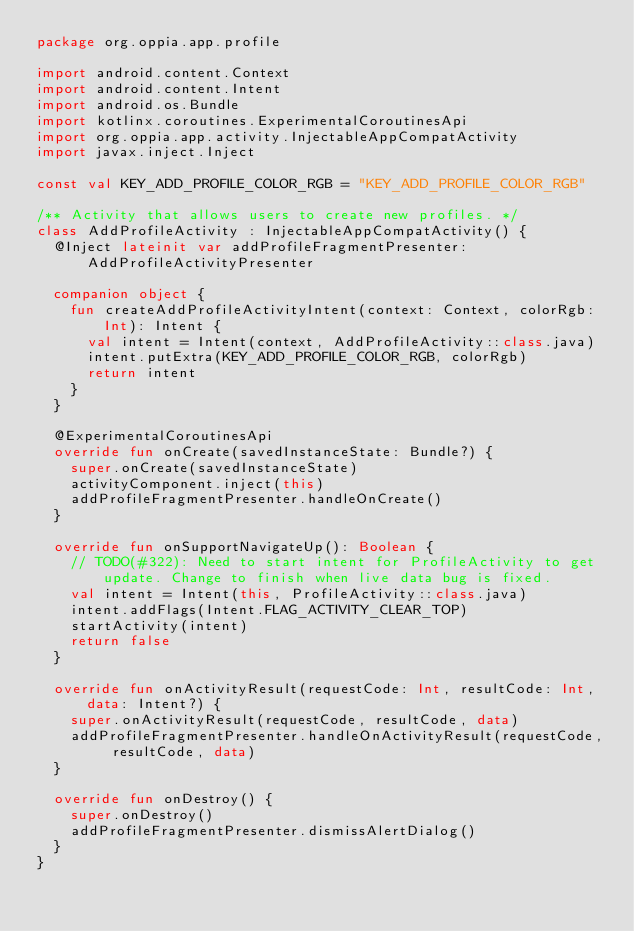<code> <loc_0><loc_0><loc_500><loc_500><_Kotlin_>package org.oppia.app.profile

import android.content.Context
import android.content.Intent
import android.os.Bundle
import kotlinx.coroutines.ExperimentalCoroutinesApi
import org.oppia.app.activity.InjectableAppCompatActivity
import javax.inject.Inject

const val KEY_ADD_PROFILE_COLOR_RGB = "KEY_ADD_PROFILE_COLOR_RGB"

/** Activity that allows users to create new profiles. */
class AddProfileActivity : InjectableAppCompatActivity() {
  @Inject lateinit var addProfileFragmentPresenter: AddProfileActivityPresenter

  companion object {
    fun createAddProfileActivityIntent(context: Context, colorRgb: Int): Intent {
      val intent = Intent(context, AddProfileActivity::class.java)
      intent.putExtra(KEY_ADD_PROFILE_COLOR_RGB, colorRgb)
      return intent
    }
  }

  @ExperimentalCoroutinesApi
  override fun onCreate(savedInstanceState: Bundle?) {
    super.onCreate(savedInstanceState)
    activityComponent.inject(this)
    addProfileFragmentPresenter.handleOnCreate()
  }

  override fun onSupportNavigateUp(): Boolean {
    // TODO(#322): Need to start intent for ProfileActivity to get update. Change to finish when live data bug is fixed.
    val intent = Intent(this, ProfileActivity::class.java)
    intent.addFlags(Intent.FLAG_ACTIVITY_CLEAR_TOP)
    startActivity(intent)
    return false
  }

  override fun onActivityResult(requestCode: Int, resultCode: Int, data: Intent?) {
    super.onActivityResult(requestCode, resultCode, data)
    addProfileFragmentPresenter.handleOnActivityResult(requestCode, resultCode, data)
  }

  override fun onDestroy() {
    super.onDestroy()
    addProfileFragmentPresenter.dismissAlertDialog()
  }
}
</code> 